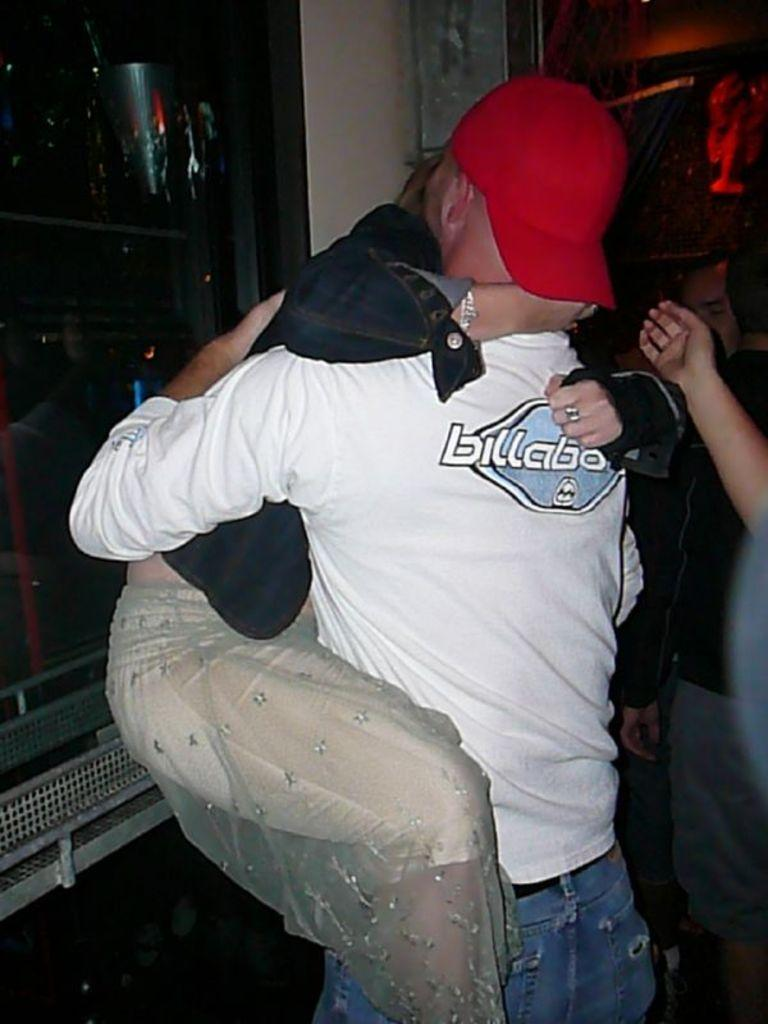What is the main subject of the image? The main subject of the image is a couple. What are the couple doing in the image? The couple is hugging each other in the image. What can be observed about the couple's attire in the image? Both individuals in the couple are wearing clothes. What type of stove can be seen in the image? There is no stove present in the image. What is the couple using to solve arithmetic problems in the image? There is no indication in the image that the couple is solving arithmetic problems or using any sticks. 